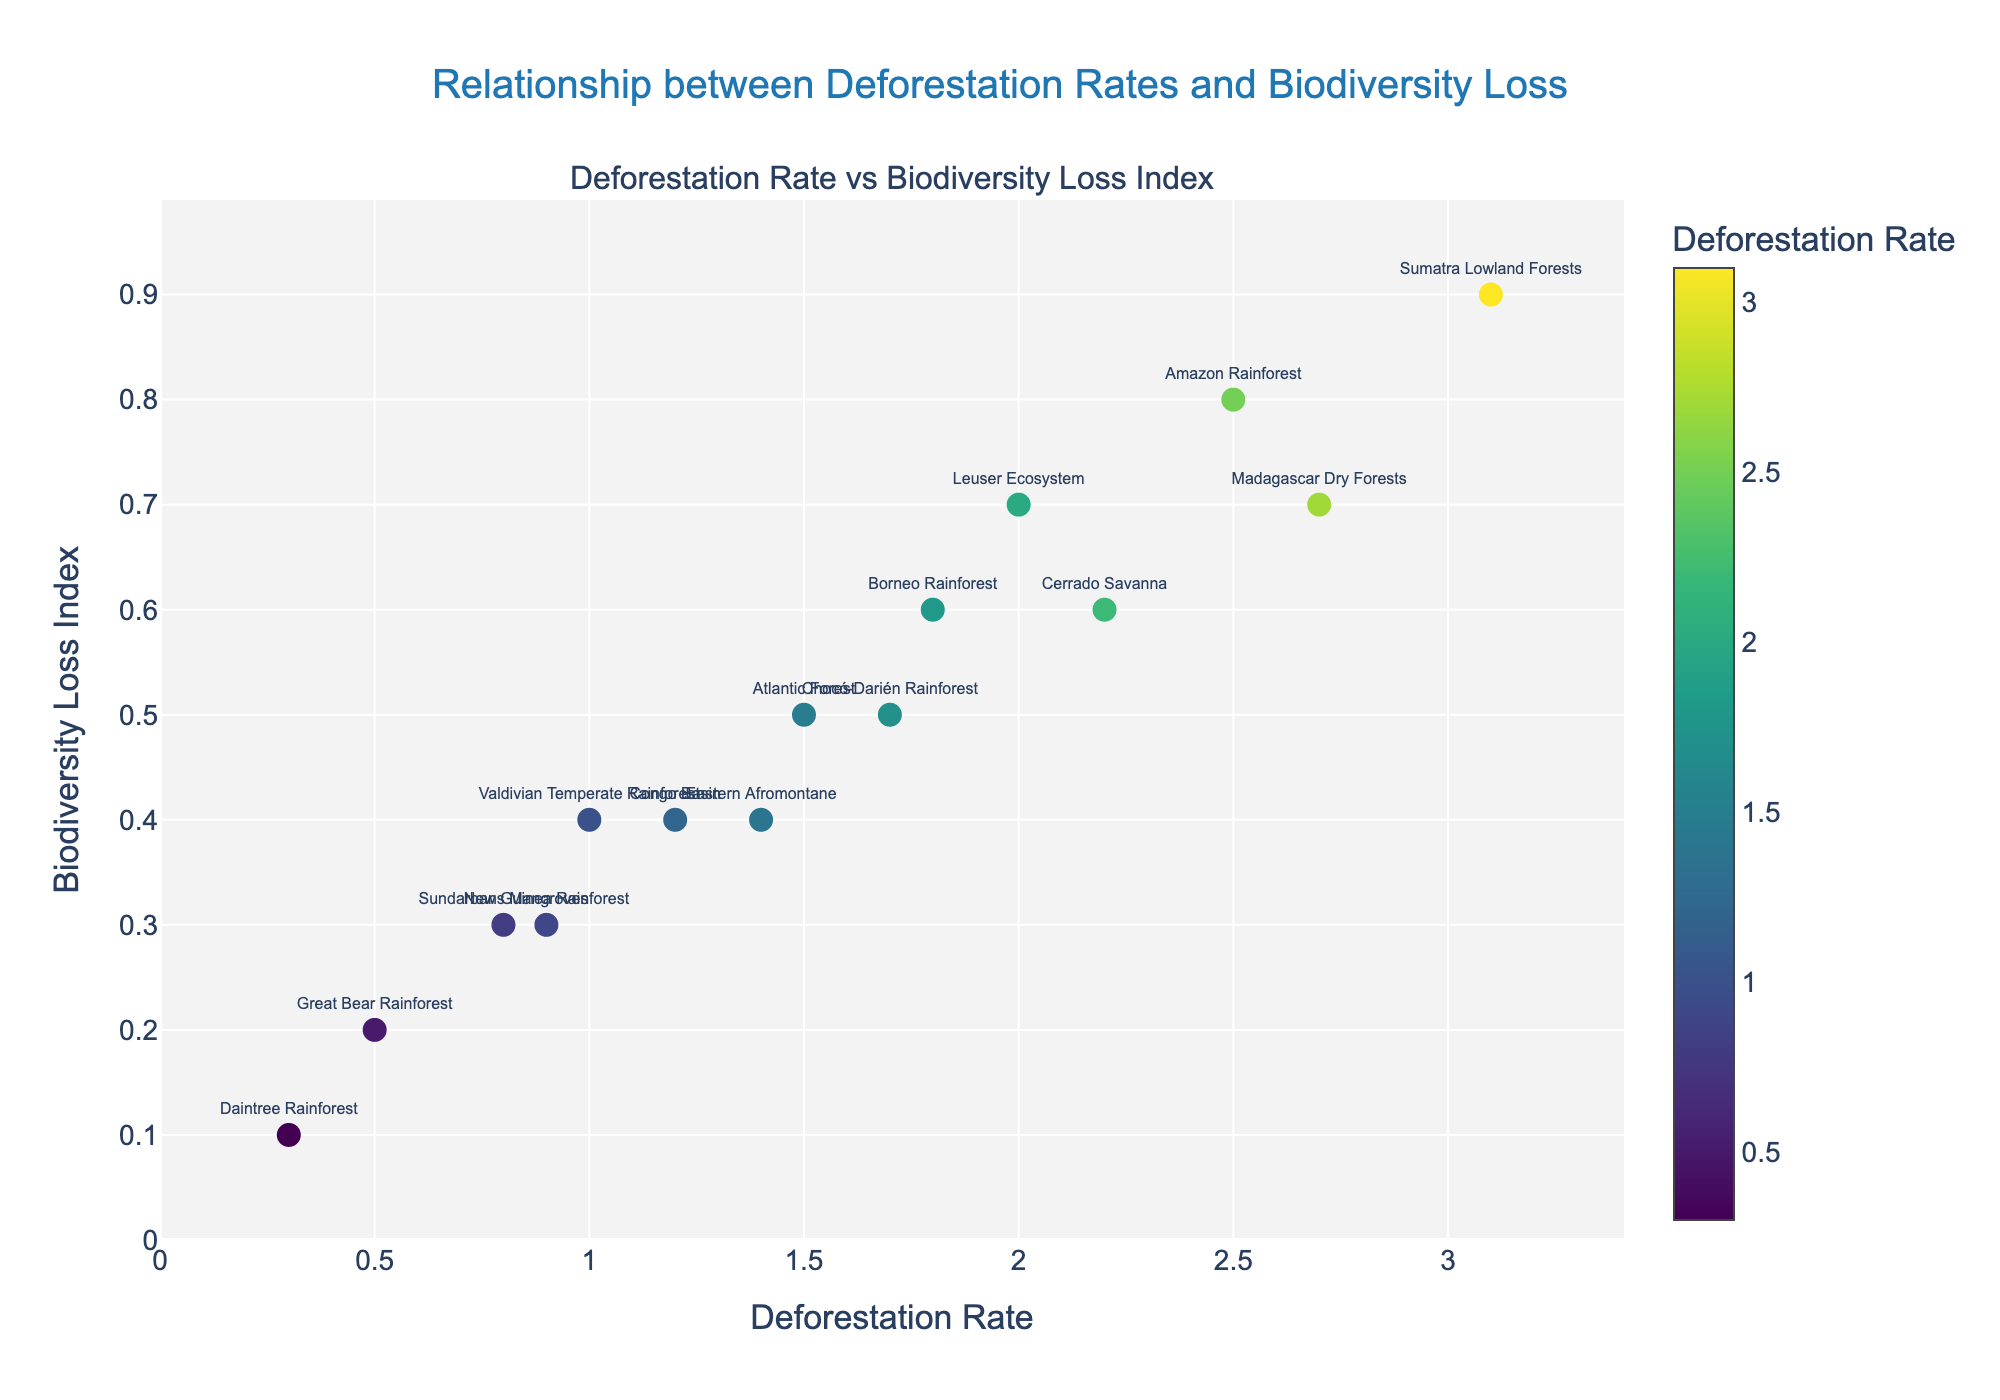How many ecosystems are represented in the figure? There are markers for each ecosystem in the figure, and counting each unique label gives us the total number of ecosystems.
Answer: 15 What's the highest deforestation rate shown? Look at the x-axis and find the maximum value among the plotted points. The highest deforestation rate is 3.1.
Answer: 3.1 Which ecosystem experiences the lowest biodiversity loss? Look at the y-axis values and find the minimum Biodiversity Loss Index, which corresponds to Daintree Rainforest.
Answer: Daintree Rainforest Is there a general trend between deforestation rate and biodiversity loss? Observing the scatter plot, a positive trend is seen where higher deforestation rates generally correspond to higher Biodiversity Loss Index values.
Answer: Positive trend What is the deforestation rate and biodiversity loss of the Amazon Rainforest? Find the marker labeled "Amazon Rainforest" on the plot and record its x and y values, which are 2.5 (Deforestation Rate) and 0.8 (Biodiversity Loss Index).
Answer: 2.5, 0.8 Which ecosystems have a Biodiversity Loss Index higher than 0.6? Look at the y-axis values to identify ecosystems above 0.6, which are Amazon Rainforest, Sumatra Lowland Forests, Madagascar Dry Forests, and Leuser Ecosystem.
Answer: Amazon Rainforest, Sumatra Lowland Forests, Madagascar Dry Forests, Leuser Ecosystem Can you find ecosystems that have both low deforestation rates (less than 1.0) and low biodiversity loss (less than 0.3)? Identify markers with x-values less than 1.0 and y-values less than 0.3. The ecosystems meeting these criteria are Daintree Rainforest, Great Bear Rainforest, and Sundarbans Mangroves.
Answer: Daintree Rainforest, Great Bear Rainforest, Sundarbans Mangroves Which ecosystem has the highest combination of deforestation rate and biodiversity loss index? Sum the x and y values of each ecosystem and compare; Sumatra Lowland Forests has the highest combination: 3.1 + 0.9 = 4.0.
Answer: Sumatra Lowland Forests Compare the deforestation rates of the Atlantic Forest and Chocó-Darién Rainforest. Which one has a higher rate? Identify the markers for both ecosystems and compare their x-values. Atlantic Forest has a deforestation rate of 1.5, while Chocó-Darién Rainforest has 1.7. Chocó-Darién Rainforest has a higher rate.
Answer: Chocó-Darién Rainforest What's the average deforestation rate of environments with a Biodiversity Loss Index of 0.4? Identify ecosystems with a y-value of 0.4, which are Congo Basin, Valdivian Temperate Rainforest, and Eastern Afromontane. Their deforestation rates are 1.2, 1.0, and 1.4. So, average (1.2 + 1.0 + 1.4) / 3 = 1.2.
Answer: 1.2 